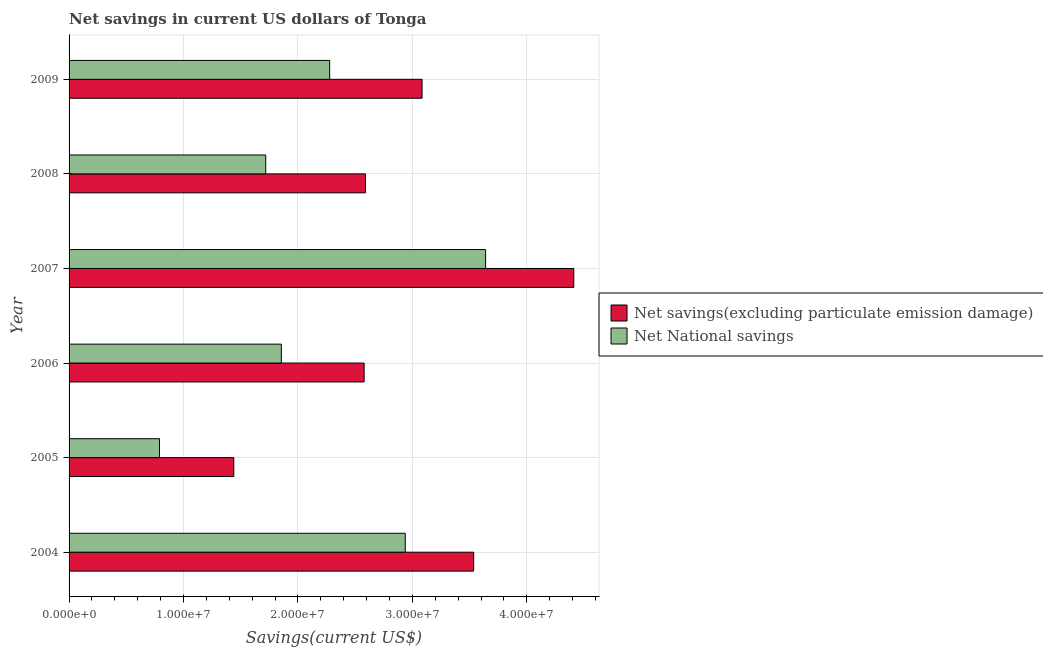How many groups of bars are there?
Offer a very short reply. 6. Are the number of bars on each tick of the Y-axis equal?
Give a very brief answer. Yes. How many bars are there on the 2nd tick from the bottom?
Offer a terse response. 2. What is the label of the 1st group of bars from the top?
Offer a very short reply. 2009. What is the net national savings in 2004?
Offer a terse response. 2.94e+07. Across all years, what is the maximum net national savings?
Give a very brief answer. 3.64e+07. Across all years, what is the minimum net savings(excluding particulate emission damage)?
Your answer should be very brief. 1.44e+07. In which year was the net national savings maximum?
Offer a terse response. 2007. What is the total net national savings in the graph?
Ensure brevity in your answer.  1.32e+08. What is the difference between the net savings(excluding particulate emission damage) in 2006 and that in 2007?
Give a very brief answer. -1.83e+07. What is the difference between the net national savings in 2009 and the net savings(excluding particulate emission damage) in 2004?
Your answer should be compact. -1.26e+07. What is the average net national savings per year?
Make the answer very short. 2.20e+07. In the year 2004, what is the difference between the net savings(excluding particulate emission damage) and net national savings?
Your response must be concise. 5.98e+06. What is the ratio of the net national savings in 2004 to that in 2006?
Your response must be concise. 1.58. Is the net savings(excluding particulate emission damage) in 2004 less than that in 2009?
Give a very brief answer. No. What is the difference between the highest and the second highest net national savings?
Give a very brief answer. 7.02e+06. What is the difference between the highest and the lowest net savings(excluding particulate emission damage)?
Your answer should be compact. 2.97e+07. In how many years, is the net savings(excluding particulate emission damage) greater than the average net savings(excluding particulate emission damage) taken over all years?
Make the answer very short. 3. Is the sum of the net national savings in 2006 and 2007 greater than the maximum net savings(excluding particulate emission damage) across all years?
Make the answer very short. Yes. What does the 1st bar from the top in 2009 represents?
Your answer should be compact. Net National savings. What does the 1st bar from the bottom in 2004 represents?
Make the answer very short. Net savings(excluding particulate emission damage). How many bars are there?
Your answer should be very brief. 12. How many years are there in the graph?
Give a very brief answer. 6. What is the difference between two consecutive major ticks on the X-axis?
Offer a terse response. 1.00e+07. Are the values on the major ticks of X-axis written in scientific E-notation?
Offer a terse response. Yes. Does the graph contain grids?
Your answer should be compact. Yes. Where does the legend appear in the graph?
Offer a terse response. Center right. How many legend labels are there?
Offer a terse response. 2. How are the legend labels stacked?
Your answer should be very brief. Vertical. What is the title of the graph?
Make the answer very short. Net savings in current US dollars of Tonga. What is the label or title of the X-axis?
Provide a short and direct response. Savings(current US$). What is the Savings(current US$) of Net savings(excluding particulate emission damage) in 2004?
Your response must be concise. 3.54e+07. What is the Savings(current US$) of Net National savings in 2004?
Your answer should be very brief. 2.94e+07. What is the Savings(current US$) of Net savings(excluding particulate emission damage) in 2005?
Your answer should be compact. 1.44e+07. What is the Savings(current US$) in Net National savings in 2005?
Your answer should be compact. 7.90e+06. What is the Savings(current US$) in Net savings(excluding particulate emission damage) in 2006?
Offer a very short reply. 2.58e+07. What is the Savings(current US$) of Net National savings in 2006?
Your response must be concise. 1.85e+07. What is the Savings(current US$) of Net savings(excluding particulate emission damage) in 2007?
Your answer should be compact. 4.41e+07. What is the Savings(current US$) in Net National savings in 2007?
Provide a succinct answer. 3.64e+07. What is the Savings(current US$) in Net savings(excluding particulate emission damage) in 2008?
Offer a very short reply. 2.59e+07. What is the Savings(current US$) of Net National savings in 2008?
Keep it short and to the point. 1.72e+07. What is the Savings(current US$) of Net savings(excluding particulate emission damage) in 2009?
Your response must be concise. 3.08e+07. What is the Savings(current US$) of Net National savings in 2009?
Your response must be concise. 2.28e+07. Across all years, what is the maximum Savings(current US$) of Net savings(excluding particulate emission damage)?
Your answer should be very brief. 4.41e+07. Across all years, what is the maximum Savings(current US$) of Net National savings?
Provide a short and direct response. 3.64e+07. Across all years, what is the minimum Savings(current US$) in Net savings(excluding particulate emission damage)?
Your answer should be compact. 1.44e+07. Across all years, what is the minimum Savings(current US$) in Net National savings?
Your answer should be very brief. 7.90e+06. What is the total Savings(current US$) of Net savings(excluding particulate emission damage) in the graph?
Your answer should be compact. 1.76e+08. What is the total Savings(current US$) of Net National savings in the graph?
Give a very brief answer. 1.32e+08. What is the difference between the Savings(current US$) in Net savings(excluding particulate emission damage) in 2004 and that in 2005?
Your answer should be compact. 2.10e+07. What is the difference between the Savings(current US$) in Net National savings in 2004 and that in 2005?
Offer a terse response. 2.15e+07. What is the difference between the Savings(current US$) of Net savings(excluding particulate emission damage) in 2004 and that in 2006?
Your answer should be compact. 9.57e+06. What is the difference between the Savings(current US$) of Net National savings in 2004 and that in 2006?
Keep it short and to the point. 1.08e+07. What is the difference between the Savings(current US$) in Net savings(excluding particulate emission damage) in 2004 and that in 2007?
Provide a succinct answer. -8.75e+06. What is the difference between the Savings(current US$) in Net National savings in 2004 and that in 2007?
Keep it short and to the point. -7.02e+06. What is the difference between the Savings(current US$) of Net savings(excluding particulate emission damage) in 2004 and that in 2008?
Your answer should be compact. 9.45e+06. What is the difference between the Savings(current US$) of Net National savings in 2004 and that in 2008?
Provide a succinct answer. 1.22e+07. What is the difference between the Savings(current US$) of Net savings(excluding particulate emission damage) in 2004 and that in 2009?
Your response must be concise. 4.51e+06. What is the difference between the Savings(current US$) of Net National savings in 2004 and that in 2009?
Ensure brevity in your answer.  6.61e+06. What is the difference between the Savings(current US$) of Net savings(excluding particulate emission damage) in 2005 and that in 2006?
Keep it short and to the point. -1.14e+07. What is the difference between the Savings(current US$) in Net National savings in 2005 and that in 2006?
Your answer should be very brief. -1.06e+07. What is the difference between the Savings(current US$) of Net savings(excluding particulate emission damage) in 2005 and that in 2007?
Your response must be concise. -2.97e+07. What is the difference between the Savings(current US$) of Net National savings in 2005 and that in 2007?
Give a very brief answer. -2.85e+07. What is the difference between the Savings(current US$) in Net savings(excluding particulate emission damage) in 2005 and that in 2008?
Your response must be concise. -1.15e+07. What is the difference between the Savings(current US$) of Net National savings in 2005 and that in 2008?
Your answer should be compact. -9.28e+06. What is the difference between the Savings(current US$) of Net savings(excluding particulate emission damage) in 2005 and that in 2009?
Provide a short and direct response. -1.65e+07. What is the difference between the Savings(current US$) of Net National savings in 2005 and that in 2009?
Provide a succinct answer. -1.49e+07. What is the difference between the Savings(current US$) of Net savings(excluding particulate emission damage) in 2006 and that in 2007?
Your answer should be compact. -1.83e+07. What is the difference between the Savings(current US$) in Net National savings in 2006 and that in 2007?
Provide a succinct answer. -1.78e+07. What is the difference between the Savings(current US$) of Net savings(excluding particulate emission damage) in 2006 and that in 2008?
Your answer should be compact. -1.22e+05. What is the difference between the Savings(current US$) in Net National savings in 2006 and that in 2008?
Your answer should be very brief. 1.36e+06. What is the difference between the Savings(current US$) in Net savings(excluding particulate emission damage) in 2006 and that in 2009?
Offer a very short reply. -5.06e+06. What is the difference between the Savings(current US$) of Net National savings in 2006 and that in 2009?
Keep it short and to the point. -4.22e+06. What is the difference between the Savings(current US$) of Net savings(excluding particulate emission damage) in 2007 and that in 2008?
Keep it short and to the point. 1.82e+07. What is the difference between the Savings(current US$) of Net National savings in 2007 and that in 2008?
Keep it short and to the point. 1.92e+07. What is the difference between the Savings(current US$) in Net savings(excluding particulate emission damage) in 2007 and that in 2009?
Provide a succinct answer. 1.33e+07. What is the difference between the Savings(current US$) of Net National savings in 2007 and that in 2009?
Keep it short and to the point. 1.36e+07. What is the difference between the Savings(current US$) in Net savings(excluding particulate emission damage) in 2008 and that in 2009?
Your answer should be compact. -4.94e+06. What is the difference between the Savings(current US$) of Net National savings in 2008 and that in 2009?
Your answer should be very brief. -5.59e+06. What is the difference between the Savings(current US$) of Net savings(excluding particulate emission damage) in 2004 and the Savings(current US$) of Net National savings in 2005?
Your answer should be very brief. 2.75e+07. What is the difference between the Savings(current US$) of Net savings(excluding particulate emission damage) in 2004 and the Savings(current US$) of Net National savings in 2006?
Your answer should be compact. 1.68e+07. What is the difference between the Savings(current US$) of Net savings(excluding particulate emission damage) in 2004 and the Savings(current US$) of Net National savings in 2007?
Make the answer very short. -1.04e+06. What is the difference between the Savings(current US$) in Net savings(excluding particulate emission damage) in 2004 and the Savings(current US$) in Net National savings in 2008?
Your answer should be very brief. 1.82e+07. What is the difference between the Savings(current US$) in Net savings(excluding particulate emission damage) in 2004 and the Savings(current US$) in Net National savings in 2009?
Make the answer very short. 1.26e+07. What is the difference between the Savings(current US$) in Net savings(excluding particulate emission damage) in 2005 and the Savings(current US$) in Net National savings in 2006?
Ensure brevity in your answer.  -4.15e+06. What is the difference between the Savings(current US$) of Net savings(excluding particulate emission damage) in 2005 and the Savings(current US$) of Net National savings in 2007?
Your response must be concise. -2.20e+07. What is the difference between the Savings(current US$) in Net savings(excluding particulate emission damage) in 2005 and the Savings(current US$) in Net National savings in 2008?
Keep it short and to the point. -2.79e+06. What is the difference between the Savings(current US$) of Net savings(excluding particulate emission damage) in 2005 and the Savings(current US$) of Net National savings in 2009?
Your answer should be compact. -8.38e+06. What is the difference between the Savings(current US$) in Net savings(excluding particulate emission damage) in 2006 and the Savings(current US$) in Net National savings in 2007?
Provide a succinct answer. -1.06e+07. What is the difference between the Savings(current US$) in Net savings(excluding particulate emission damage) in 2006 and the Savings(current US$) in Net National savings in 2008?
Keep it short and to the point. 8.60e+06. What is the difference between the Savings(current US$) in Net savings(excluding particulate emission damage) in 2006 and the Savings(current US$) in Net National savings in 2009?
Your response must be concise. 3.01e+06. What is the difference between the Savings(current US$) in Net savings(excluding particulate emission damage) in 2007 and the Savings(current US$) in Net National savings in 2008?
Your response must be concise. 2.69e+07. What is the difference between the Savings(current US$) of Net savings(excluding particulate emission damage) in 2007 and the Savings(current US$) of Net National savings in 2009?
Your response must be concise. 2.13e+07. What is the difference between the Savings(current US$) in Net savings(excluding particulate emission damage) in 2008 and the Savings(current US$) in Net National savings in 2009?
Keep it short and to the point. 3.14e+06. What is the average Savings(current US$) of Net savings(excluding particulate emission damage) per year?
Provide a succinct answer. 2.94e+07. What is the average Savings(current US$) in Net National savings per year?
Provide a succinct answer. 2.20e+07. In the year 2004, what is the difference between the Savings(current US$) of Net savings(excluding particulate emission damage) and Savings(current US$) of Net National savings?
Provide a succinct answer. 5.98e+06. In the year 2005, what is the difference between the Savings(current US$) of Net savings(excluding particulate emission damage) and Savings(current US$) of Net National savings?
Offer a terse response. 6.49e+06. In the year 2006, what is the difference between the Savings(current US$) of Net savings(excluding particulate emission damage) and Savings(current US$) of Net National savings?
Give a very brief answer. 7.23e+06. In the year 2007, what is the difference between the Savings(current US$) in Net savings(excluding particulate emission damage) and Savings(current US$) in Net National savings?
Provide a short and direct response. 7.71e+06. In the year 2008, what is the difference between the Savings(current US$) in Net savings(excluding particulate emission damage) and Savings(current US$) in Net National savings?
Offer a terse response. 8.72e+06. In the year 2009, what is the difference between the Savings(current US$) in Net savings(excluding particulate emission damage) and Savings(current US$) in Net National savings?
Offer a terse response. 8.08e+06. What is the ratio of the Savings(current US$) of Net savings(excluding particulate emission damage) in 2004 to that in 2005?
Make the answer very short. 2.46. What is the ratio of the Savings(current US$) of Net National savings in 2004 to that in 2005?
Give a very brief answer. 3.72. What is the ratio of the Savings(current US$) of Net savings(excluding particulate emission damage) in 2004 to that in 2006?
Keep it short and to the point. 1.37. What is the ratio of the Savings(current US$) of Net National savings in 2004 to that in 2006?
Give a very brief answer. 1.58. What is the ratio of the Savings(current US$) of Net savings(excluding particulate emission damage) in 2004 to that in 2007?
Your answer should be very brief. 0.8. What is the ratio of the Savings(current US$) in Net National savings in 2004 to that in 2007?
Give a very brief answer. 0.81. What is the ratio of the Savings(current US$) of Net savings(excluding particulate emission damage) in 2004 to that in 2008?
Your response must be concise. 1.36. What is the ratio of the Savings(current US$) in Net National savings in 2004 to that in 2008?
Keep it short and to the point. 1.71. What is the ratio of the Savings(current US$) of Net savings(excluding particulate emission damage) in 2004 to that in 2009?
Provide a succinct answer. 1.15. What is the ratio of the Savings(current US$) of Net National savings in 2004 to that in 2009?
Your response must be concise. 1.29. What is the ratio of the Savings(current US$) in Net savings(excluding particulate emission damage) in 2005 to that in 2006?
Offer a terse response. 0.56. What is the ratio of the Savings(current US$) in Net National savings in 2005 to that in 2006?
Keep it short and to the point. 0.43. What is the ratio of the Savings(current US$) in Net savings(excluding particulate emission damage) in 2005 to that in 2007?
Ensure brevity in your answer.  0.33. What is the ratio of the Savings(current US$) of Net National savings in 2005 to that in 2007?
Your answer should be compact. 0.22. What is the ratio of the Savings(current US$) in Net savings(excluding particulate emission damage) in 2005 to that in 2008?
Your answer should be compact. 0.56. What is the ratio of the Savings(current US$) of Net National savings in 2005 to that in 2008?
Your answer should be very brief. 0.46. What is the ratio of the Savings(current US$) in Net savings(excluding particulate emission damage) in 2005 to that in 2009?
Give a very brief answer. 0.47. What is the ratio of the Savings(current US$) in Net National savings in 2005 to that in 2009?
Offer a terse response. 0.35. What is the ratio of the Savings(current US$) in Net savings(excluding particulate emission damage) in 2006 to that in 2007?
Your answer should be very brief. 0.58. What is the ratio of the Savings(current US$) in Net National savings in 2006 to that in 2007?
Ensure brevity in your answer.  0.51. What is the ratio of the Savings(current US$) of Net National savings in 2006 to that in 2008?
Your answer should be compact. 1.08. What is the ratio of the Savings(current US$) of Net savings(excluding particulate emission damage) in 2006 to that in 2009?
Provide a succinct answer. 0.84. What is the ratio of the Savings(current US$) of Net National savings in 2006 to that in 2009?
Offer a very short reply. 0.81. What is the ratio of the Savings(current US$) of Net savings(excluding particulate emission damage) in 2007 to that in 2008?
Give a very brief answer. 1.7. What is the ratio of the Savings(current US$) of Net National savings in 2007 to that in 2008?
Keep it short and to the point. 2.12. What is the ratio of the Savings(current US$) in Net savings(excluding particulate emission damage) in 2007 to that in 2009?
Your response must be concise. 1.43. What is the ratio of the Savings(current US$) of Net National savings in 2007 to that in 2009?
Provide a succinct answer. 1.6. What is the ratio of the Savings(current US$) of Net savings(excluding particulate emission damage) in 2008 to that in 2009?
Give a very brief answer. 0.84. What is the ratio of the Savings(current US$) in Net National savings in 2008 to that in 2009?
Your answer should be compact. 0.75. What is the difference between the highest and the second highest Savings(current US$) of Net savings(excluding particulate emission damage)?
Keep it short and to the point. 8.75e+06. What is the difference between the highest and the second highest Savings(current US$) in Net National savings?
Offer a terse response. 7.02e+06. What is the difference between the highest and the lowest Savings(current US$) of Net savings(excluding particulate emission damage)?
Offer a very short reply. 2.97e+07. What is the difference between the highest and the lowest Savings(current US$) in Net National savings?
Your answer should be compact. 2.85e+07. 